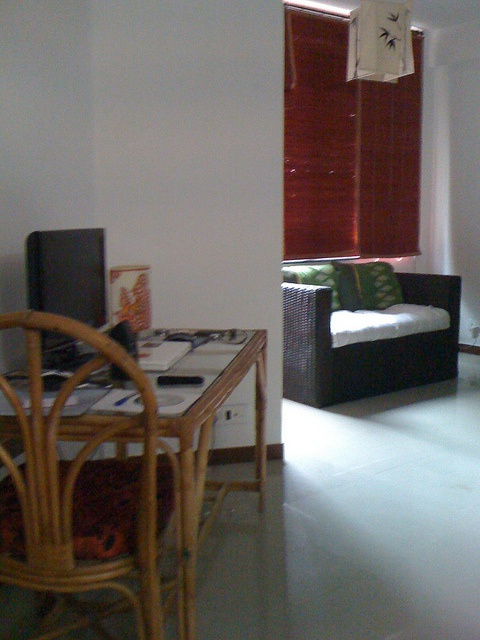Describe the objects in this image and their specific colors. I can see chair in gray, black, and maroon tones, couch in gray, black, white, and darkgray tones, tv in gray and black tones, laptop in gray tones, and remote in gray and black tones in this image. 